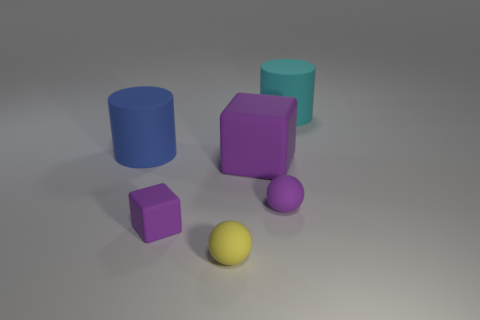Subtract all cubes. How many objects are left? 4 Subtract all cyan cylinders. How many cylinders are left? 1 Add 6 tiny matte blocks. How many tiny matte blocks are left? 7 Add 4 big purple rubber things. How many big purple rubber things exist? 5 Add 3 cubes. How many objects exist? 9 Subtract 0 yellow cylinders. How many objects are left? 6 Subtract 2 blocks. How many blocks are left? 0 Subtract all red blocks. Subtract all yellow cylinders. How many blocks are left? 2 Subtract all green balls. How many purple cylinders are left? 0 Subtract all blocks. Subtract all spheres. How many objects are left? 2 